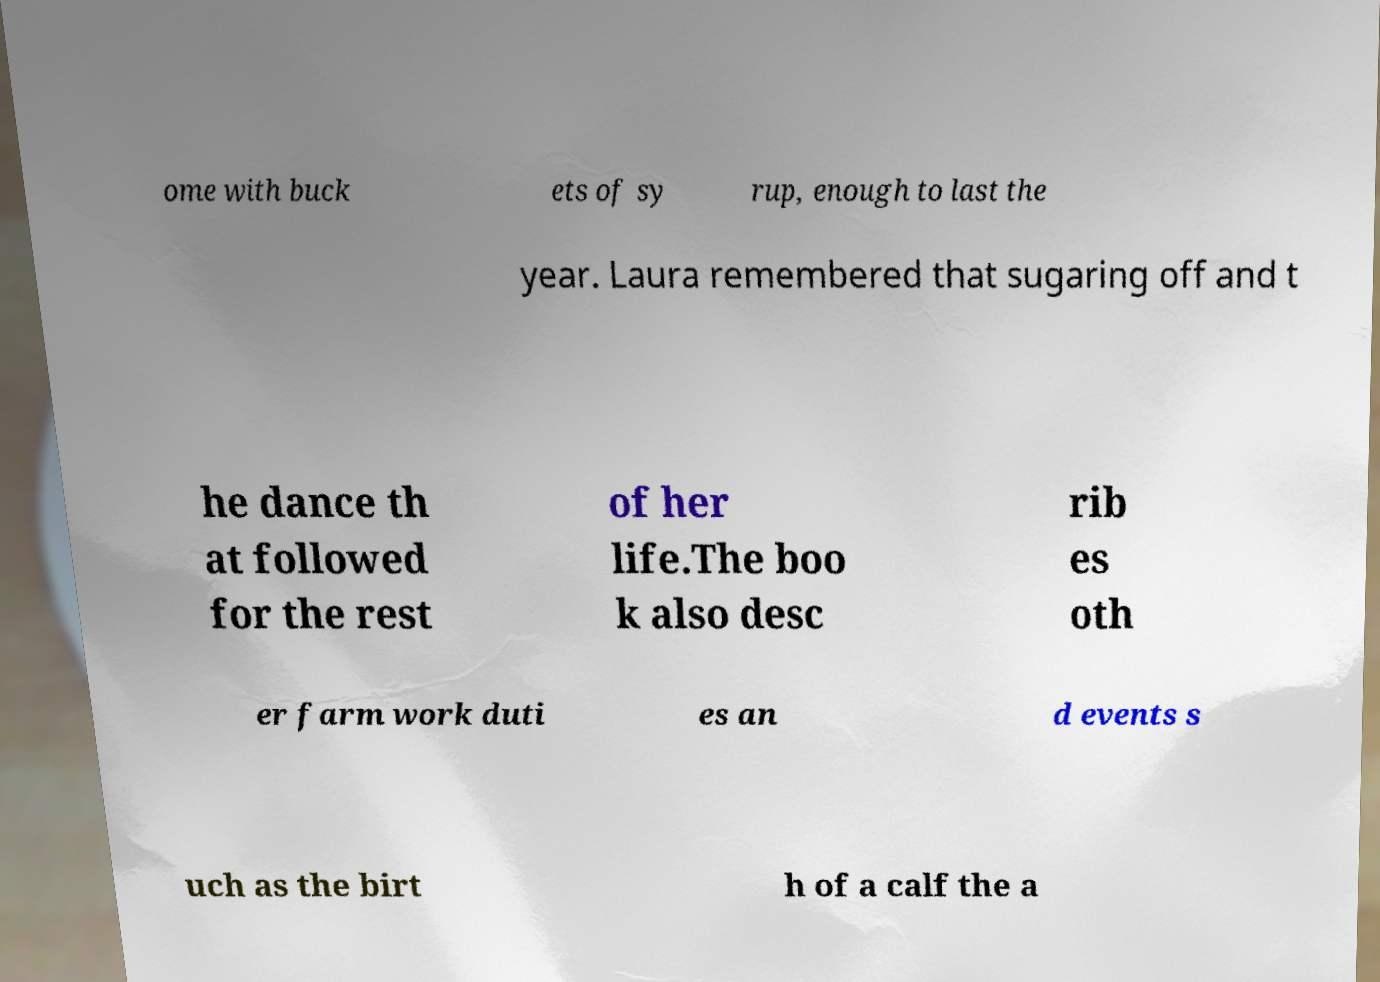Could you assist in decoding the text presented in this image and type it out clearly? ome with buck ets of sy rup, enough to last the year. Laura remembered that sugaring off and t he dance th at followed for the rest of her life.The boo k also desc rib es oth er farm work duti es an d events s uch as the birt h of a calf the a 